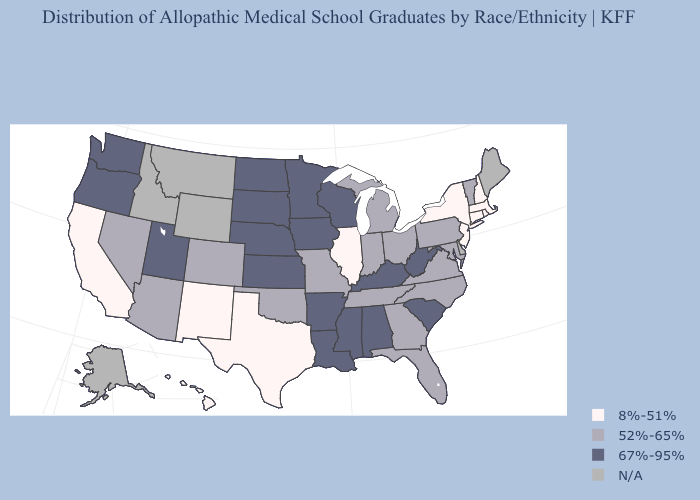Does Mississippi have the lowest value in the USA?
Short answer required. No. Does Vermont have the lowest value in the Northeast?
Write a very short answer. No. What is the highest value in the South ?
Answer briefly. 67%-95%. What is the value of Georgia?
Concise answer only. 52%-65%. Name the states that have a value in the range 8%-51%?
Keep it brief. California, Connecticut, Hawaii, Illinois, Massachusetts, New Hampshire, New Jersey, New Mexico, New York, Rhode Island, Texas. What is the lowest value in states that border Minnesota?
Concise answer only. 67%-95%. What is the lowest value in the West?
Concise answer only. 8%-51%. What is the lowest value in the Northeast?
Answer briefly. 8%-51%. Name the states that have a value in the range N/A?
Answer briefly. Alaska, Delaware, Idaho, Maine, Montana, Wyoming. What is the value of Delaware?
Quick response, please. N/A. Name the states that have a value in the range N/A?
Concise answer only. Alaska, Delaware, Idaho, Maine, Montana, Wyoming. What is the value of North Dakota?
Answer briefly. 67%-95%. What is the lowest value in the USA?
Be succinct. 8%-51%. Which states have the lowest value in the MidWest?
Answer briefly. Illinois. What is the value of Wyoming?
Concise answer only. N/A. 